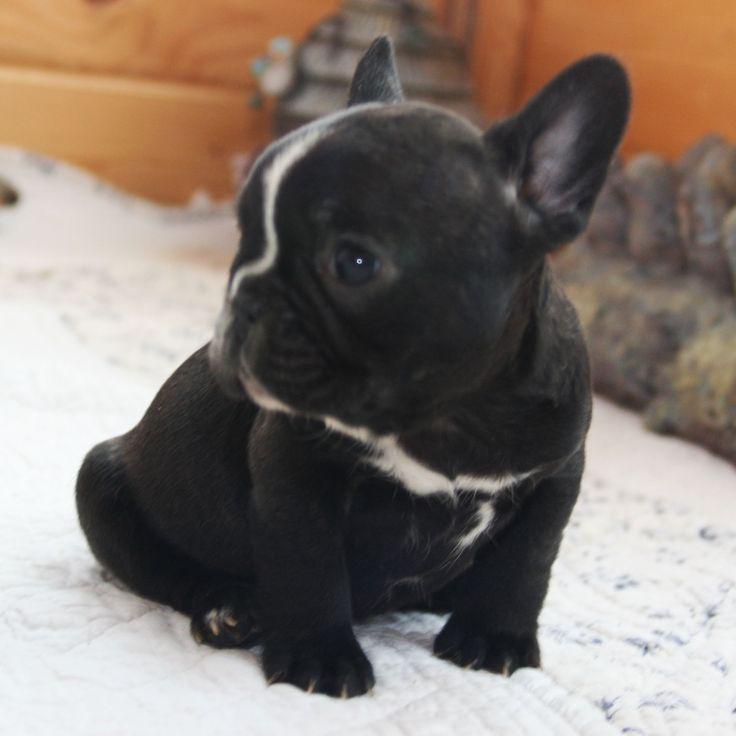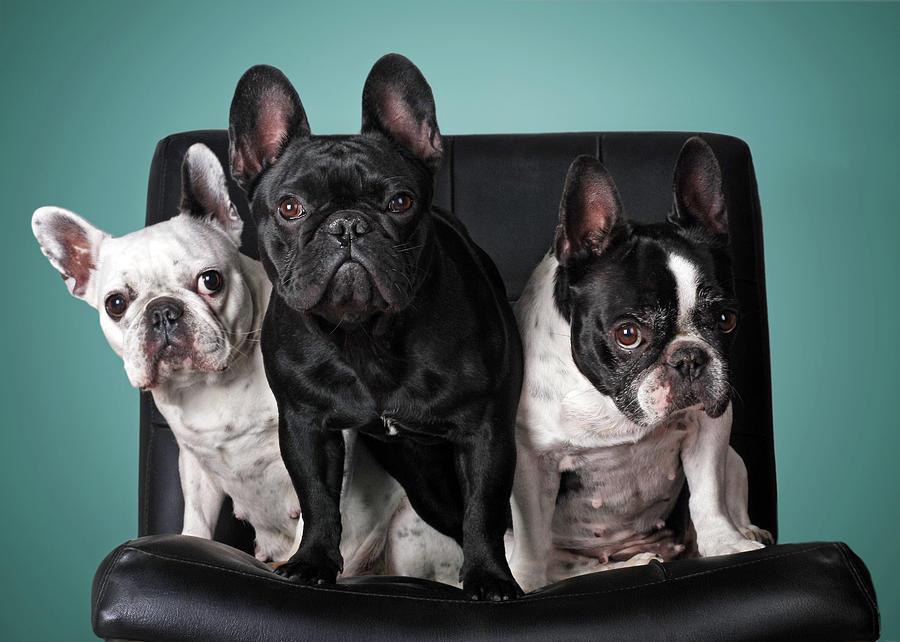The first image is the image on the left, the second image is the image on the right. Evaluate the accuracy of this statement regarding the images: "the image pair has no more than 4 puppies". Is it true? Answer yes or no. Yes. The first image is the image on the left, the second image is the image on the right. Examine the images to the left and right. Is the description "There is an image with no more and no less than two dogs." accurate? Answer yes or no. No. 